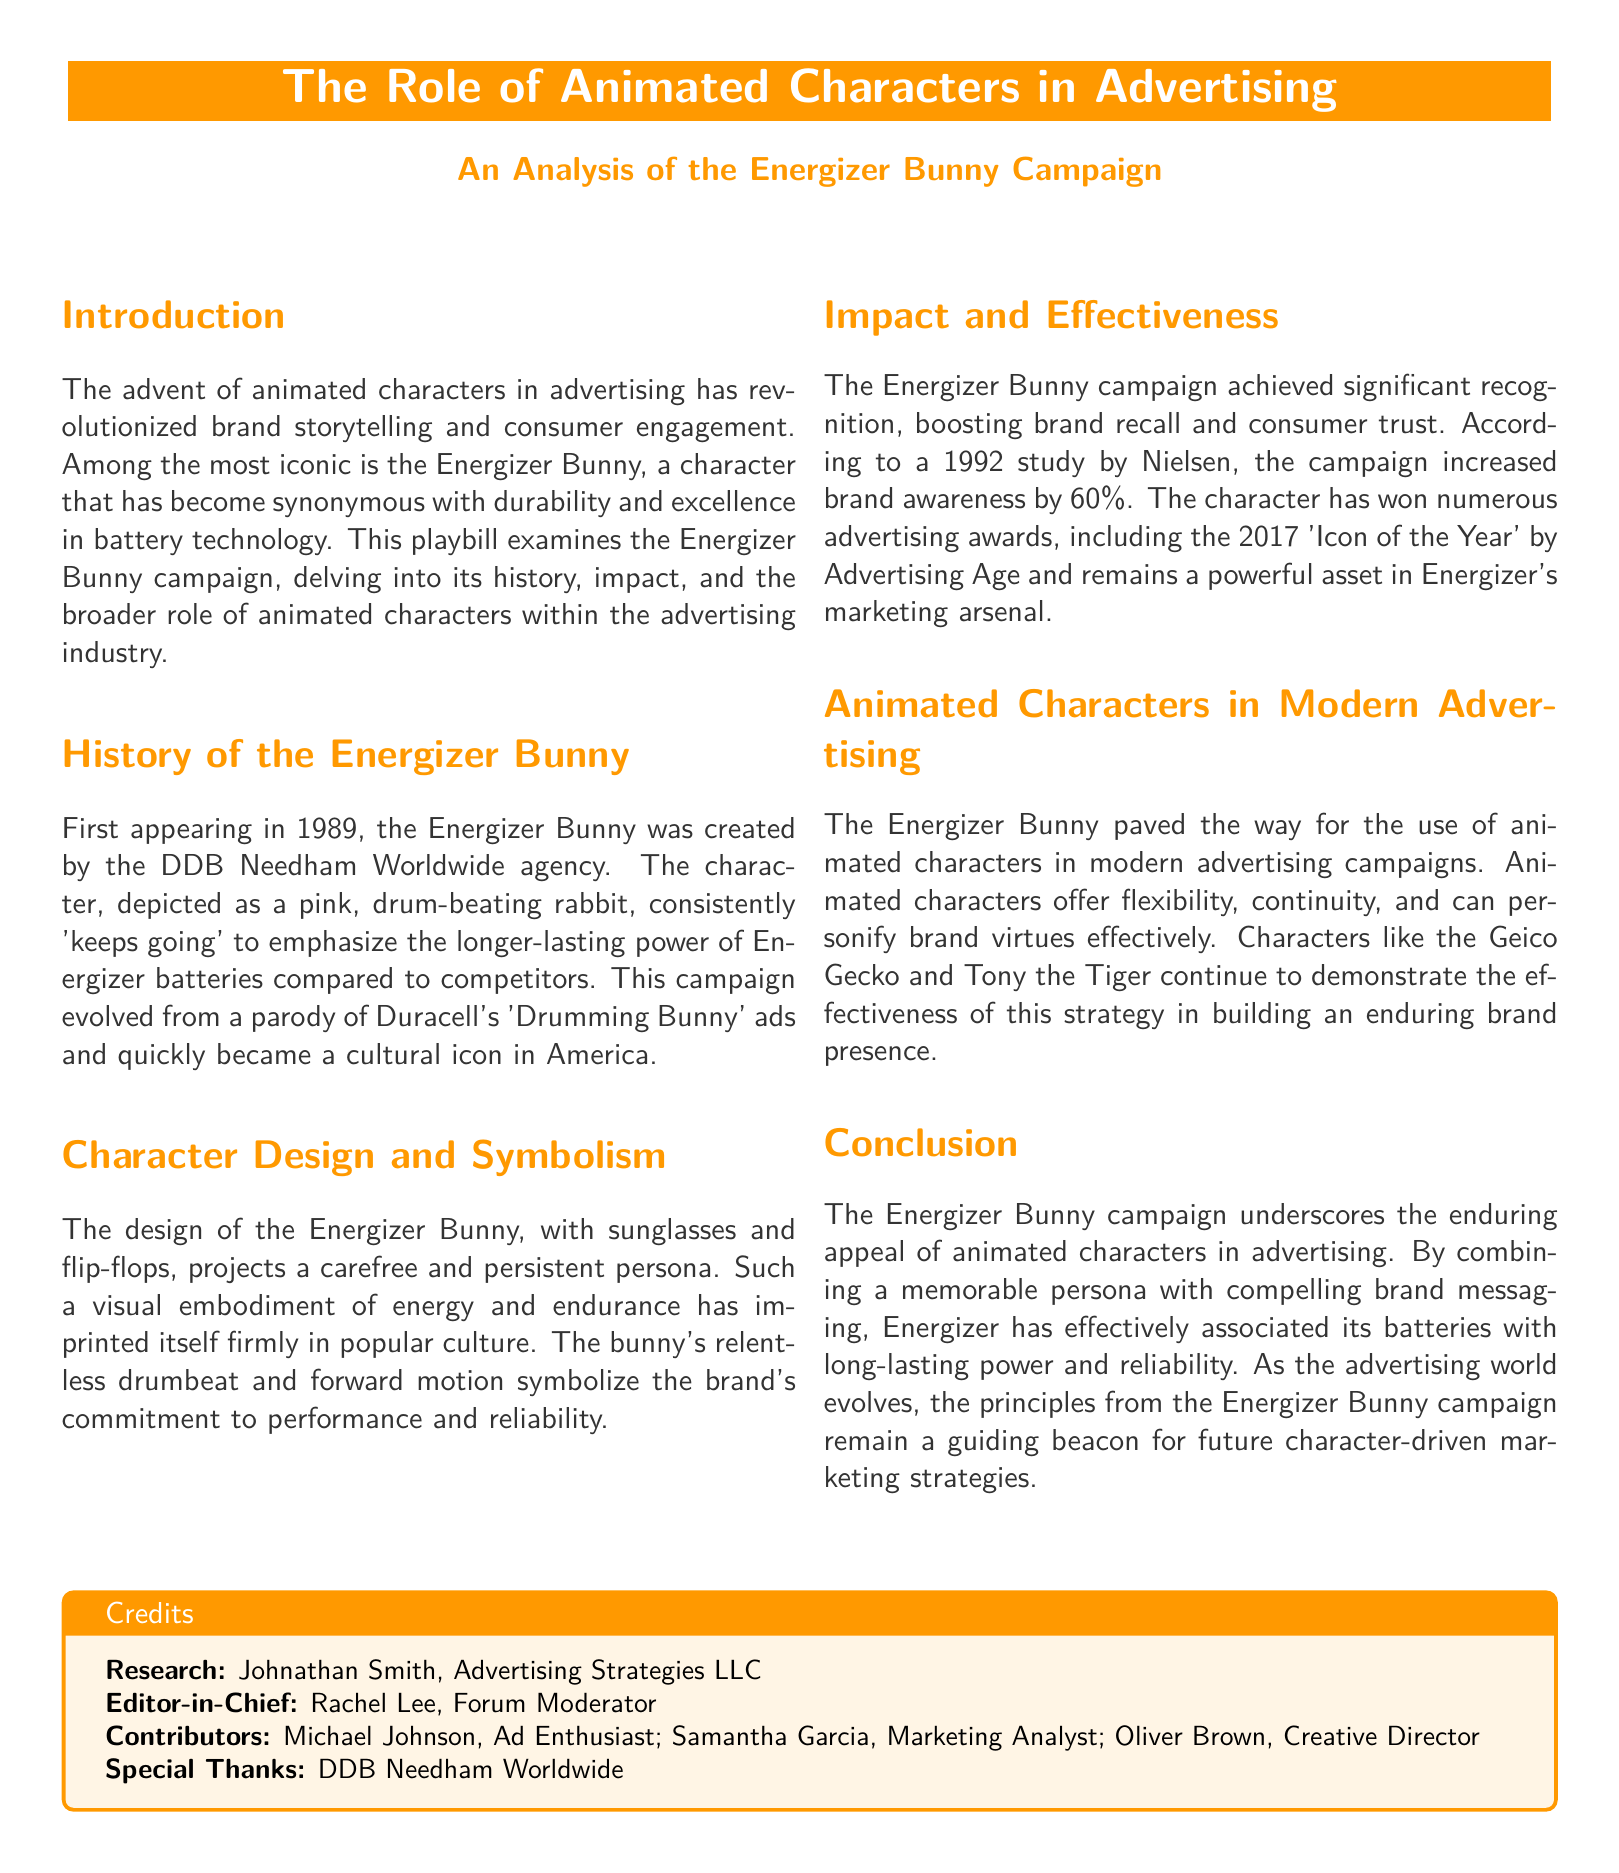What year did the Energizer Bunny first appear? The document states that the Energizer Bunny first appeared in 1989.
Answer: 1989 Who created the Energizer Bunny? According to the document, the Energizer Bunny was created by the DDB Needham Worldwide agency.
Answer: DDB Needham Worldwide What was the increase in brand awareness reported by Nielsen in 1992? The document indicates that the campaign increased brand awareness by 60%.
Answer: 60% What character design elements are mentioned in the document? The document describes the Energizer Bunny as wearing sunglasses and flip-flops.
Answer: Sunglasses and flip-flops What is a key theme associated with the Energizer Bunny? The document discusses the theme of durability and long-lasting power associated with the Energizer Bunny.
Answer: Durability What advertising award did the Energizer Bunny win in 2017? As mentioned in the document, the character won the 'Icon of the Year' award by Advertising Age in 2017.
Answer: 'Icon of the Year' Which other animated characters are mentioned as examples in modern advertising? The document mentions the Geico Gecko and Tony the Tiger as examples of animated characters in advertising.
Answer: Geico Gecko and Tony the Tiger What is the role of animated characters in modern advertising according to the document? The document states that animated characters offer flexibility, continuity, and can personify brand virtues effectively.
Answer: Flexibility, continuity, and personification of brand virtues 